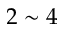Convert formula to latex. <formula><loc_0><loc_0><loc_500><loc_500>2 \sim 4</formula> 